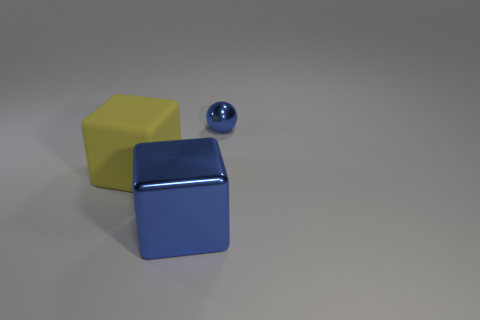Add 1 cubes. How many objects exist? 4 Subtract 0 brown spheres. How many objects are left? 3 Subtract all balls. How many objects are left? 2 Subtract all tiny green spheres. Subtract all yellow cubes. How many objects are left? 2 Add 1 blue balls. How many blue balls are left? 2 Add 3 yellow matte blocks. How many yellow matte blocks exist? 4 